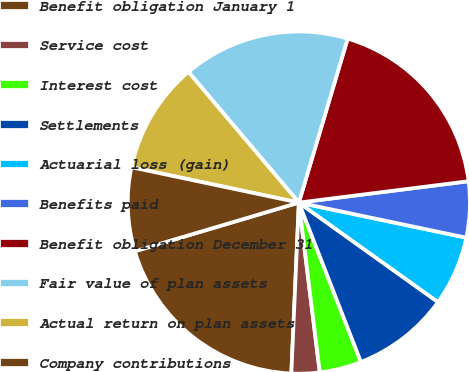<chart> <loc_0><loc_0><loc_500><loc_500><pie_chart><fcel>Benefit obligation January 1<fcel>Service cost<fcel>Interest cost<fcel>Settlements<fcel>Actuarial loss (gain)<fcel>Benefits paid<fcel>Benefit obligation December 31<fcel>Fair value of plan assets<fcel>Actual return on plan assets<fcel>Company contributions<nl><fcel>19.71%<fcel>2.65%<fcel>3.96%<fcel>9.21%<fcel>6.59%<fcel>5.28%<fcel>18.4%<fcel>15.77%<fcel>10.52%<fcel>7.9%<nl></chart> 